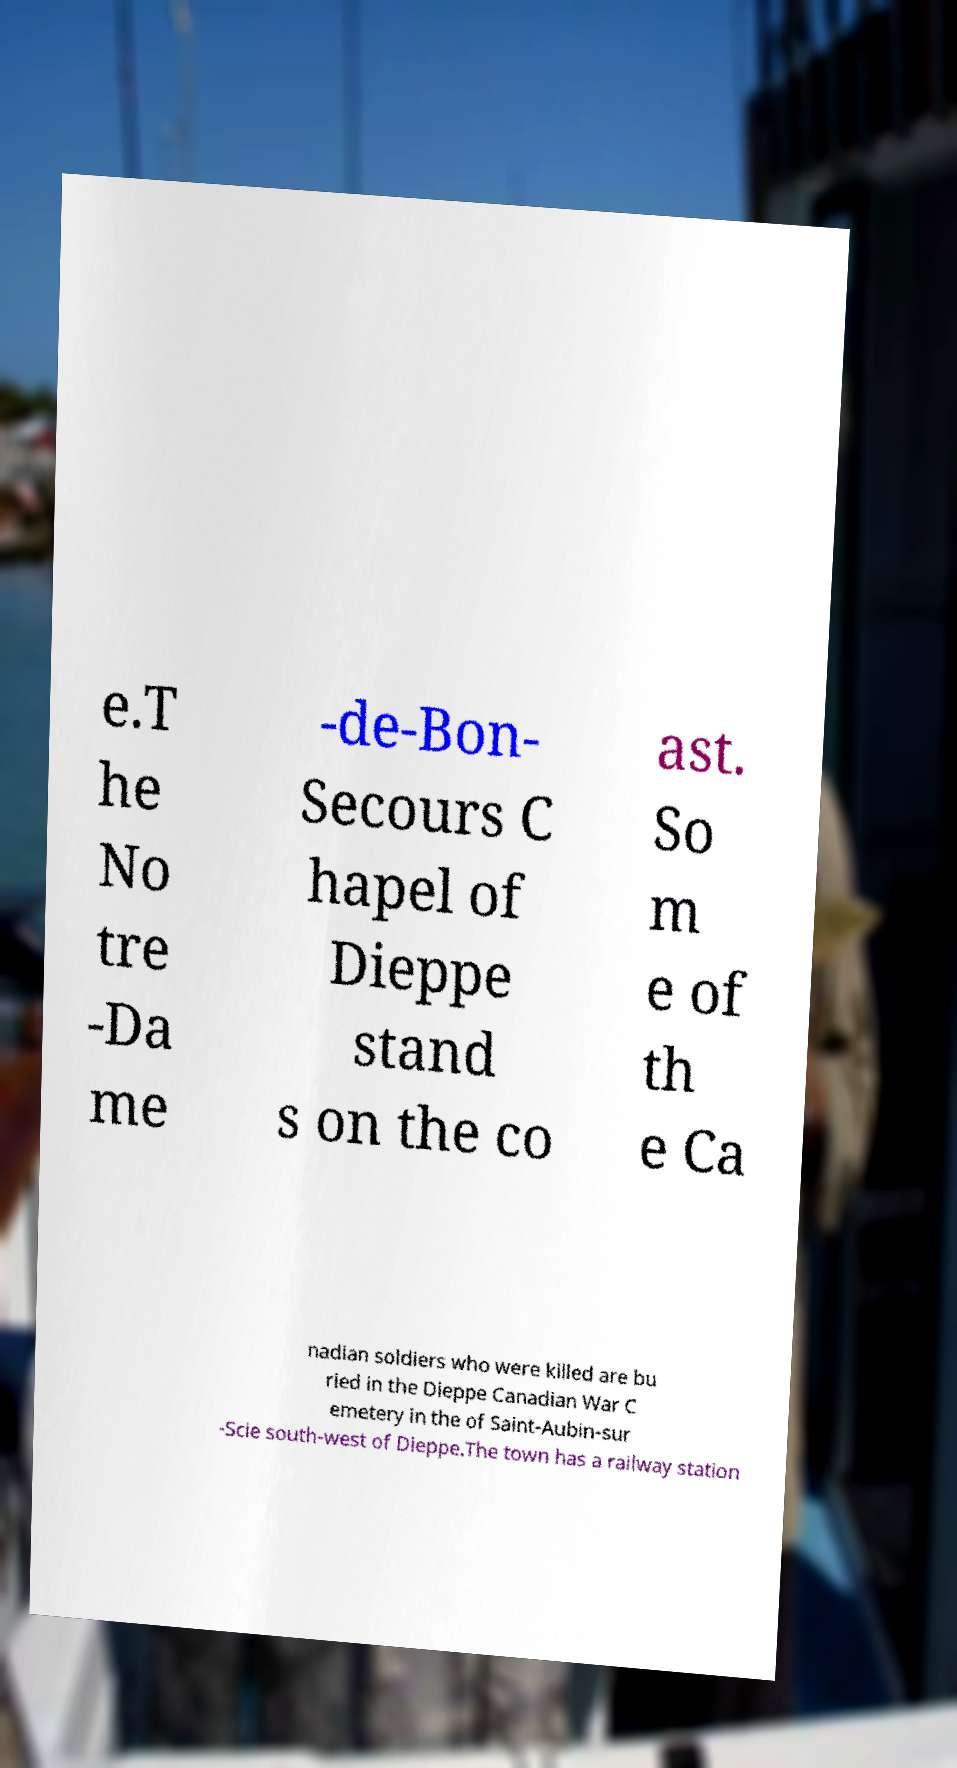What messages or text are displayed in this image? I need them in a readable, typed format. e.T he No tre -Da me -de-Bon- Secours C hapel of Dieppe stand s on the co ast. So m e of th e Ca nadian soldiers who were killed are bu ried in the Dieppe Canadian War C emetery in the of Saint-Aubin-sur -Scie south-west of Dieppe.The town has a railway station 